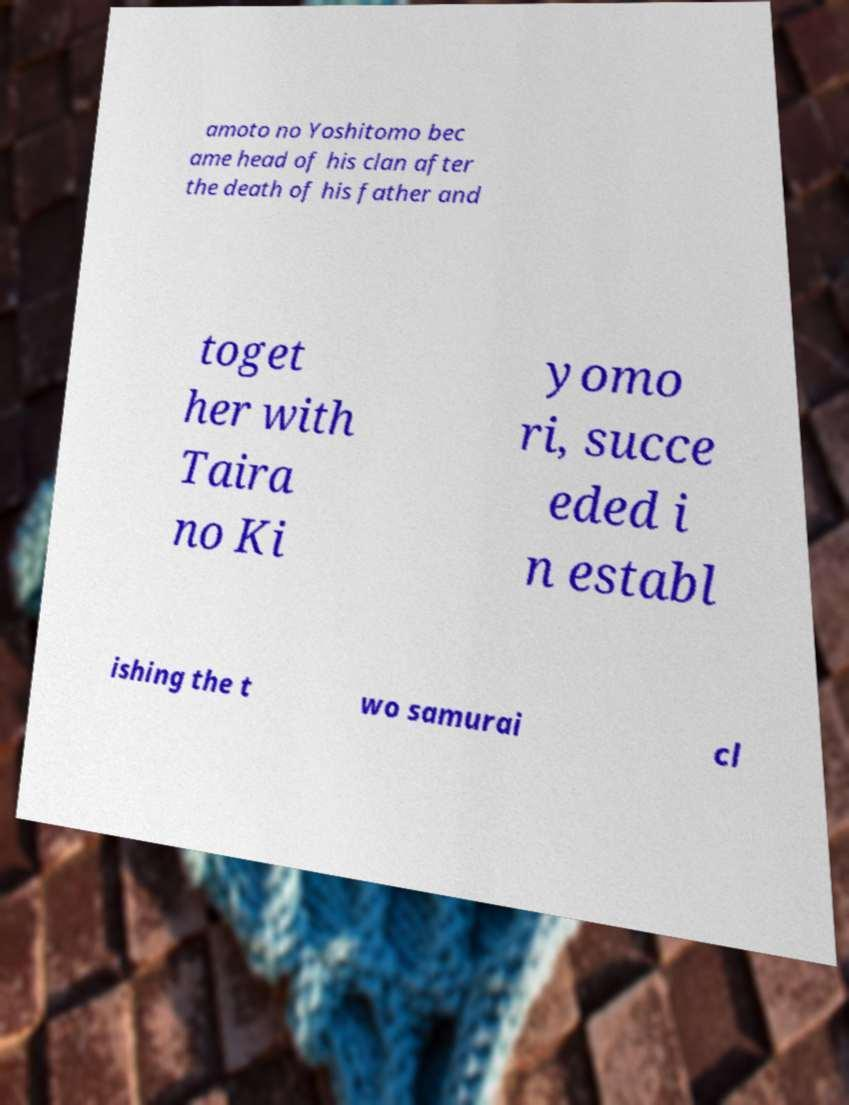Could you extract and type out the text from this image? amoto no Yoshitomo bec ame head of his clan after the death of his father and toget her with Taira no Ki yomo ri, succe eded i n establ ishing the t wo samurai cl 